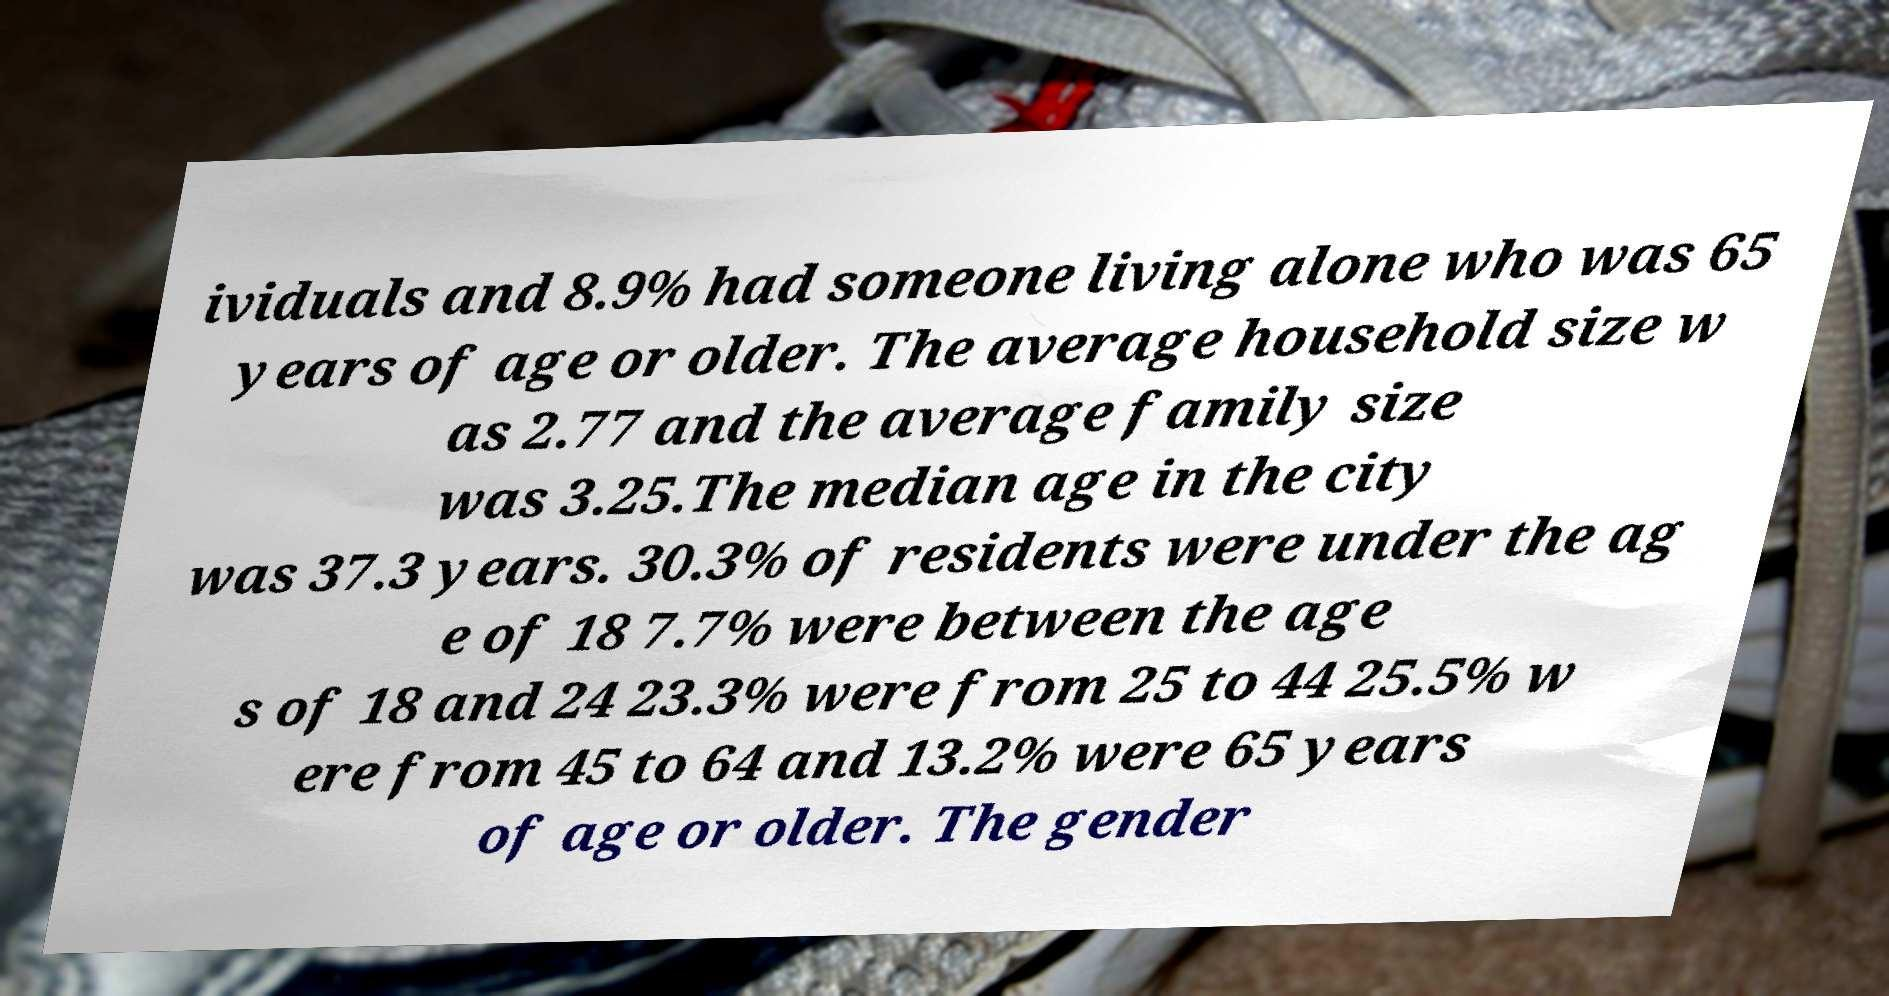For documentation purposes, I need the text within this image transcribed. Could you provide that? ividuals and 8.9% had someone living alone who was 65 years of age or older. The average household size w as 2.77 and the average family size was 3.25.The median age in the city was 37.3 years. 30.3% of residents were under the ag e of 18 7.7% were between the age s of 18 and 24 23.3% were from 25 to 44 25.5% w ere from 45 to 64 and 13.2% were 65 years of age or older. The gender 